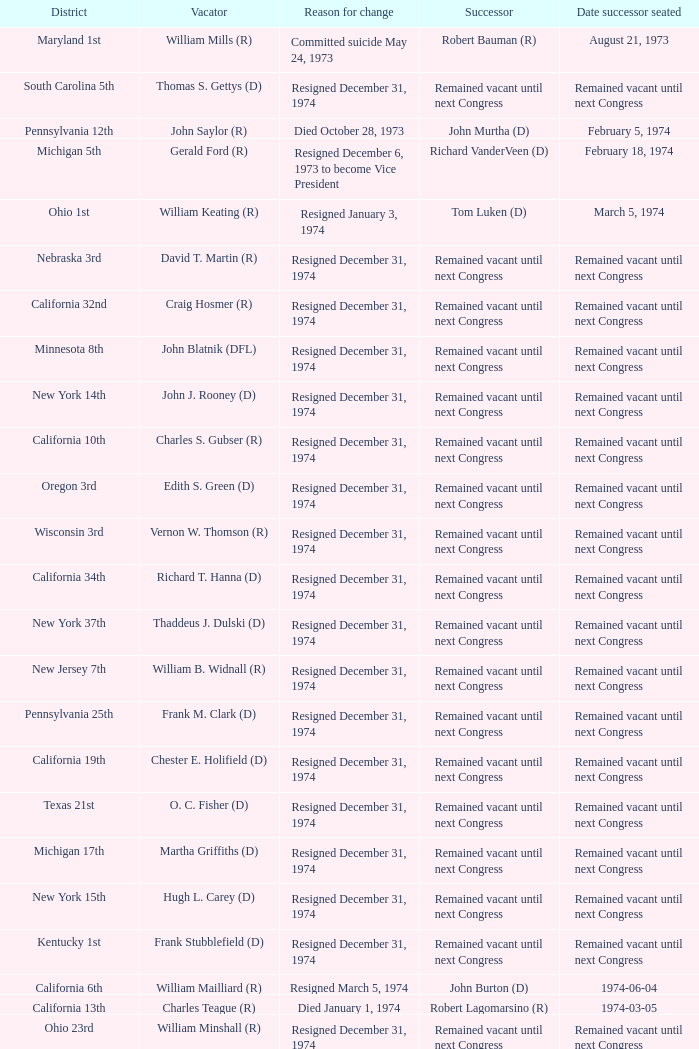When was the successor seated when the district was California 10th? Remained vacant until next Congress. 